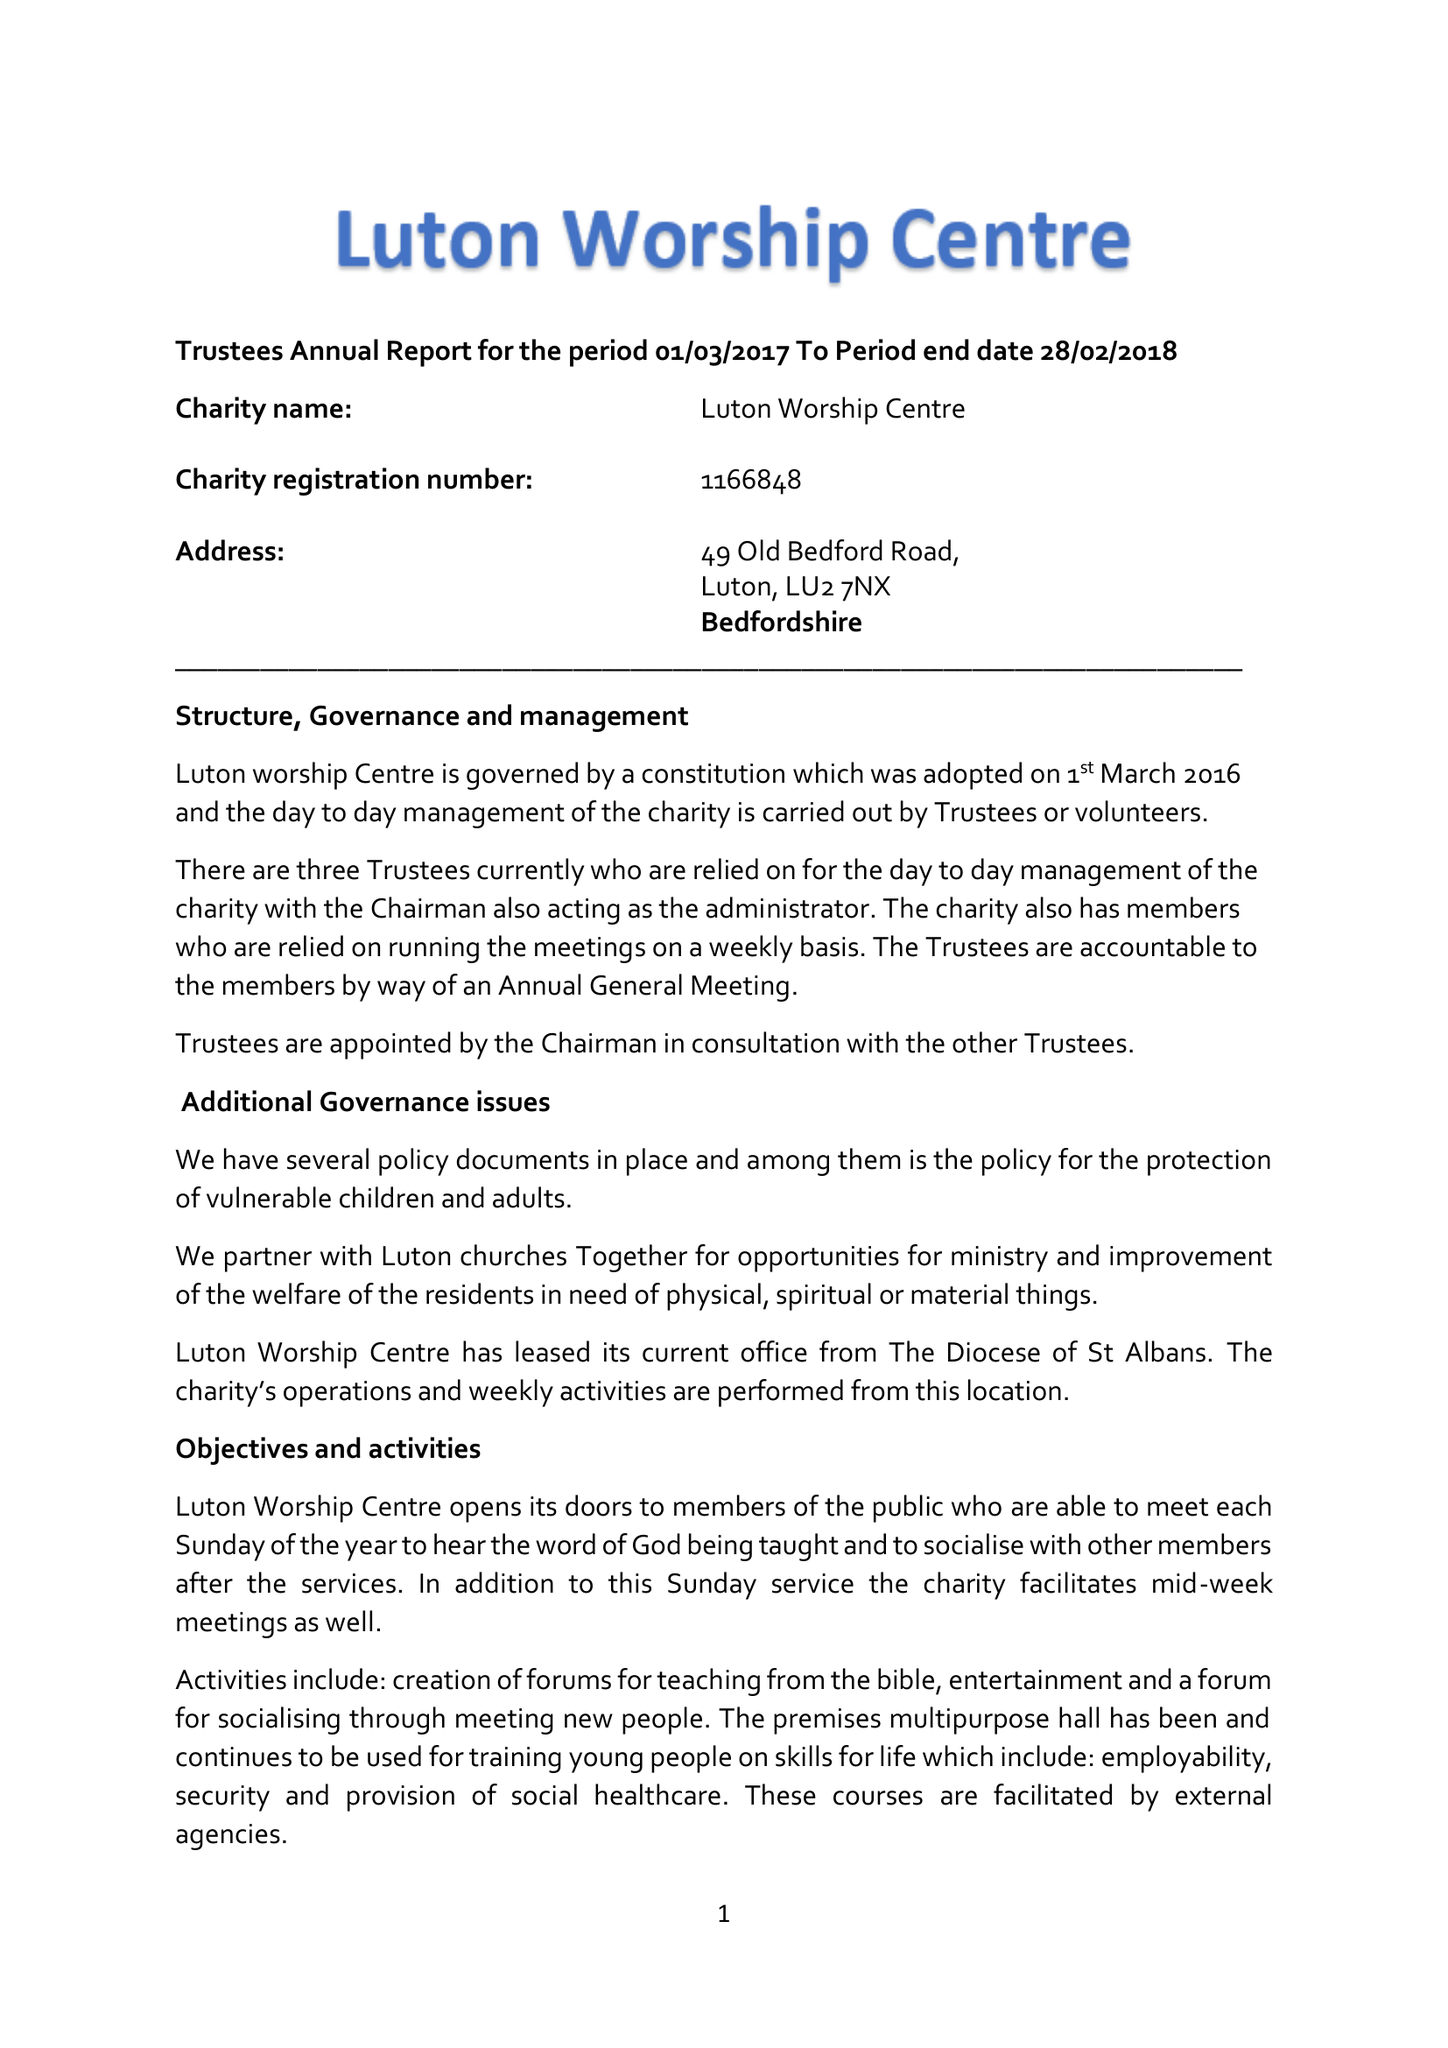What is the value for the address__street_line?
Answer the question using a single word or phrase. 49 OLD BEDFORD ROAD 